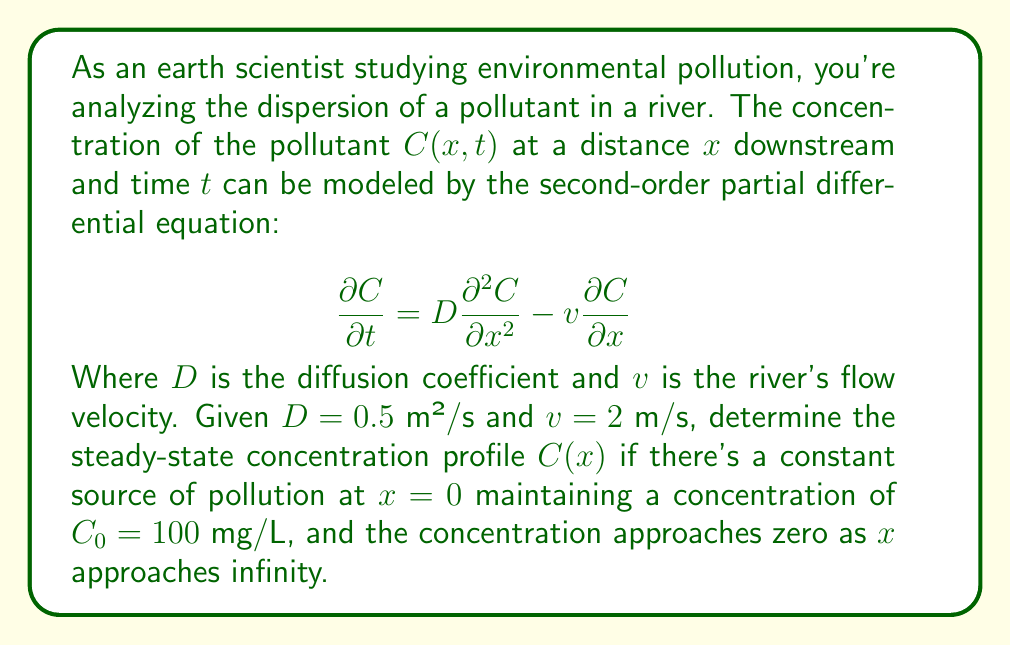What is the answer to this math problem? Let's solve this problem step-by-step:

1) For steady-state conditions, $\frac{\partial C}{\partial t} = 0$. Our equation becomes:

   $$0 = D\frac{d^2C}{dx^2} - v\frac{dC}{dx}$$

2) Rearranging:

   $$D\frac{d^2C}{dx^2} = v\frac{dC}{dx}$$

3) Dividing both sides by $D$:

   $$\frac{d^2C}{dx^2} = \frac{v}{D}\frac{dC}{dx}$$

4) Let $y = \frac{dC}{dx}$. Then our equation becomes:

   $$\frac{dy}{dx} = \frac{v}{D}y$$

5) This is a separable first-order ODE. Solving:

   $$\int \frac{dy}{y} = \int \frac{v}{D}dx$$
   $$\ln|y| = \frac{v}{D}x + K_1$$
   $$y = K_2e^{\frac{v}{D}x}$$

6) Substituting back $y = \frac{dC}{dx}$:

   $$\frac{dC}{dx} = K_2e^{\frac{v}{D}x}$$

7) Integrating again:

   $$C = -\frac{K_2D}{v}e^{\frac{v}{D}x} + K_3$$

8) Using the boundary conditions:
   - As $x \to \infty$, $C \to 0$, so $K_3 = 0$
   - At $x = 0$, $C = C_0 = 100$, so $-\frac{K_2D}{v} = 100$

9) Therefore, our solution is:

   $$C(x) = C_0e^{-\frac{v}{D}x}$$

10) Substituting the given values:

    $$C(x) = 100e^{-\frac{2}{0.5}x} = 100e^{-4x}$$

This equation describes the steady-state concentration profile of the pollutant along the river.
Answer: $C(x) = 100e^{-4x}$ mg/L 